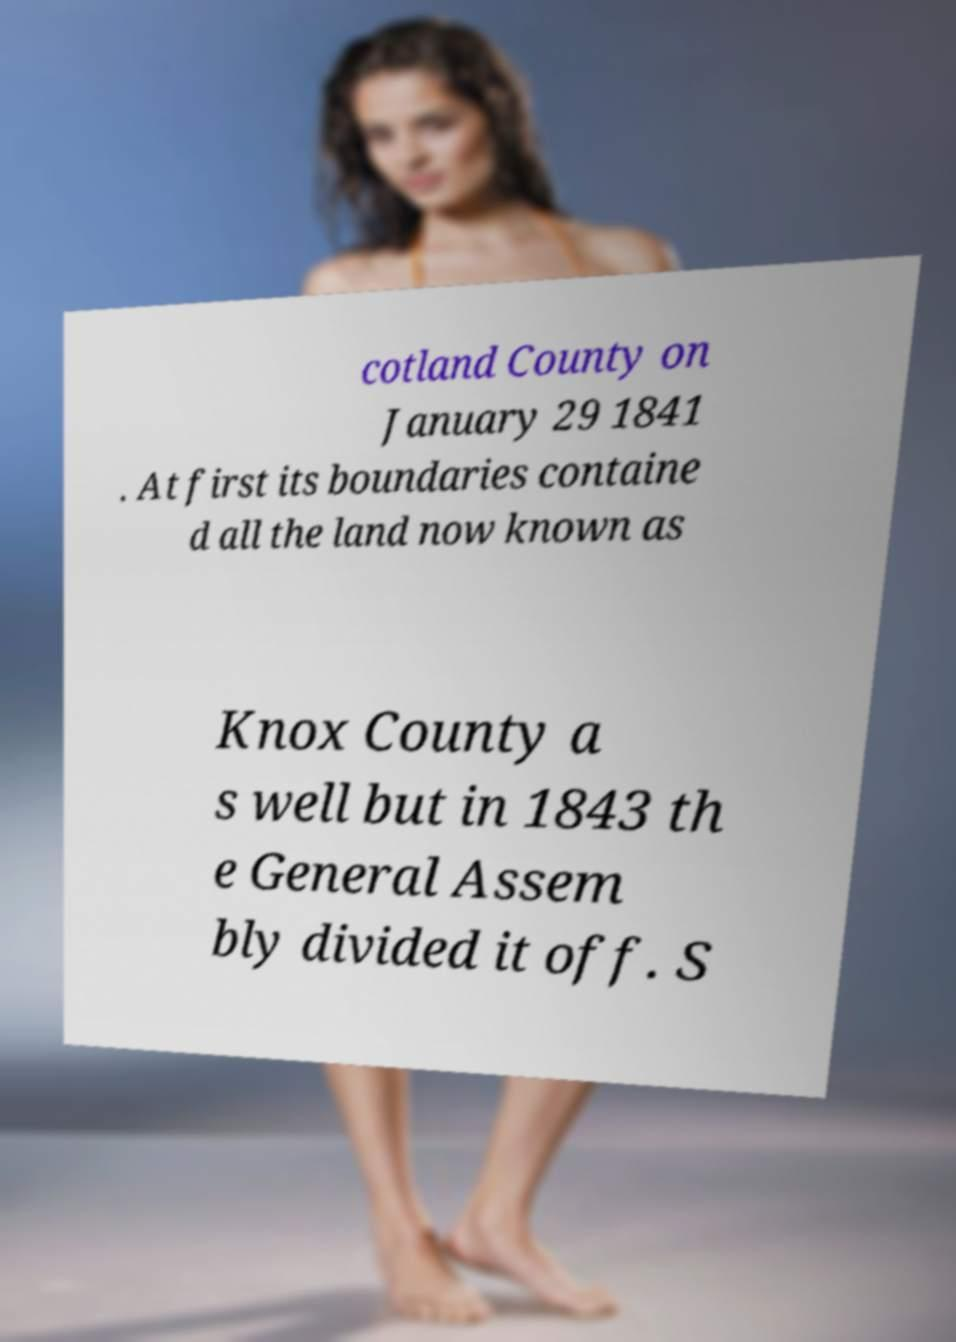I need the written content from this picture converted into text. Can you do that? cotland County on January 29 1841 . At first its boundaries containe d all the land now known as Knox County a s well but in 1843 th e General Assem bly divided it off. S 